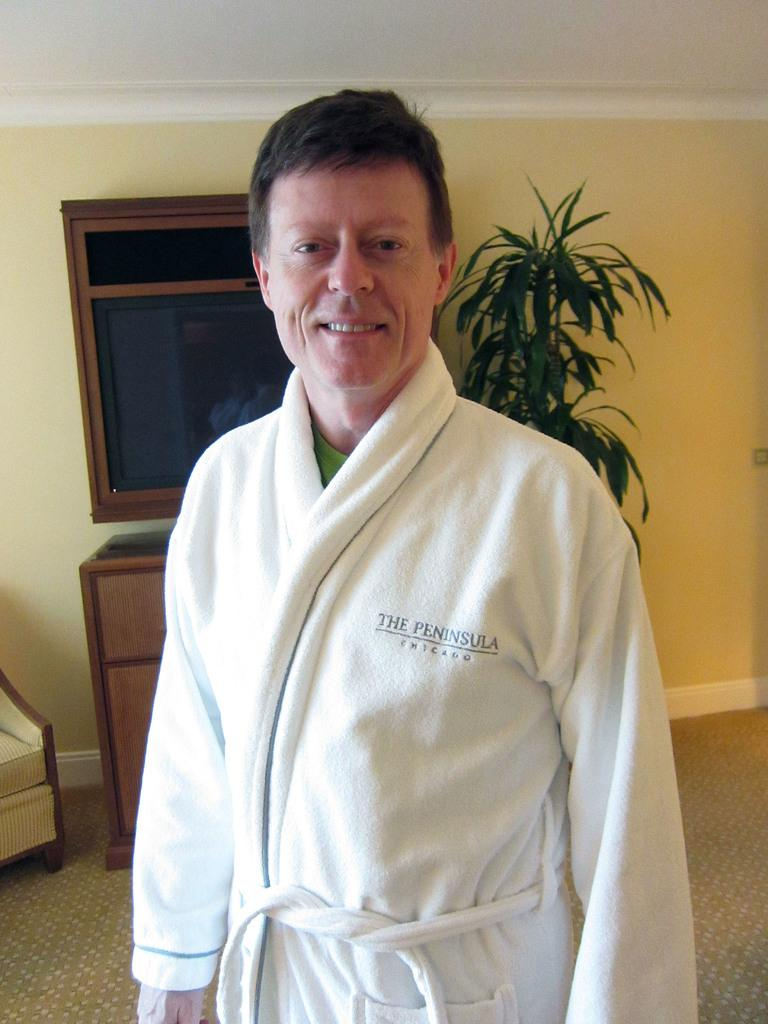<image>
Relay a brief, clear account of the picture shown. man in white bathrobe from the peninsula hotel 